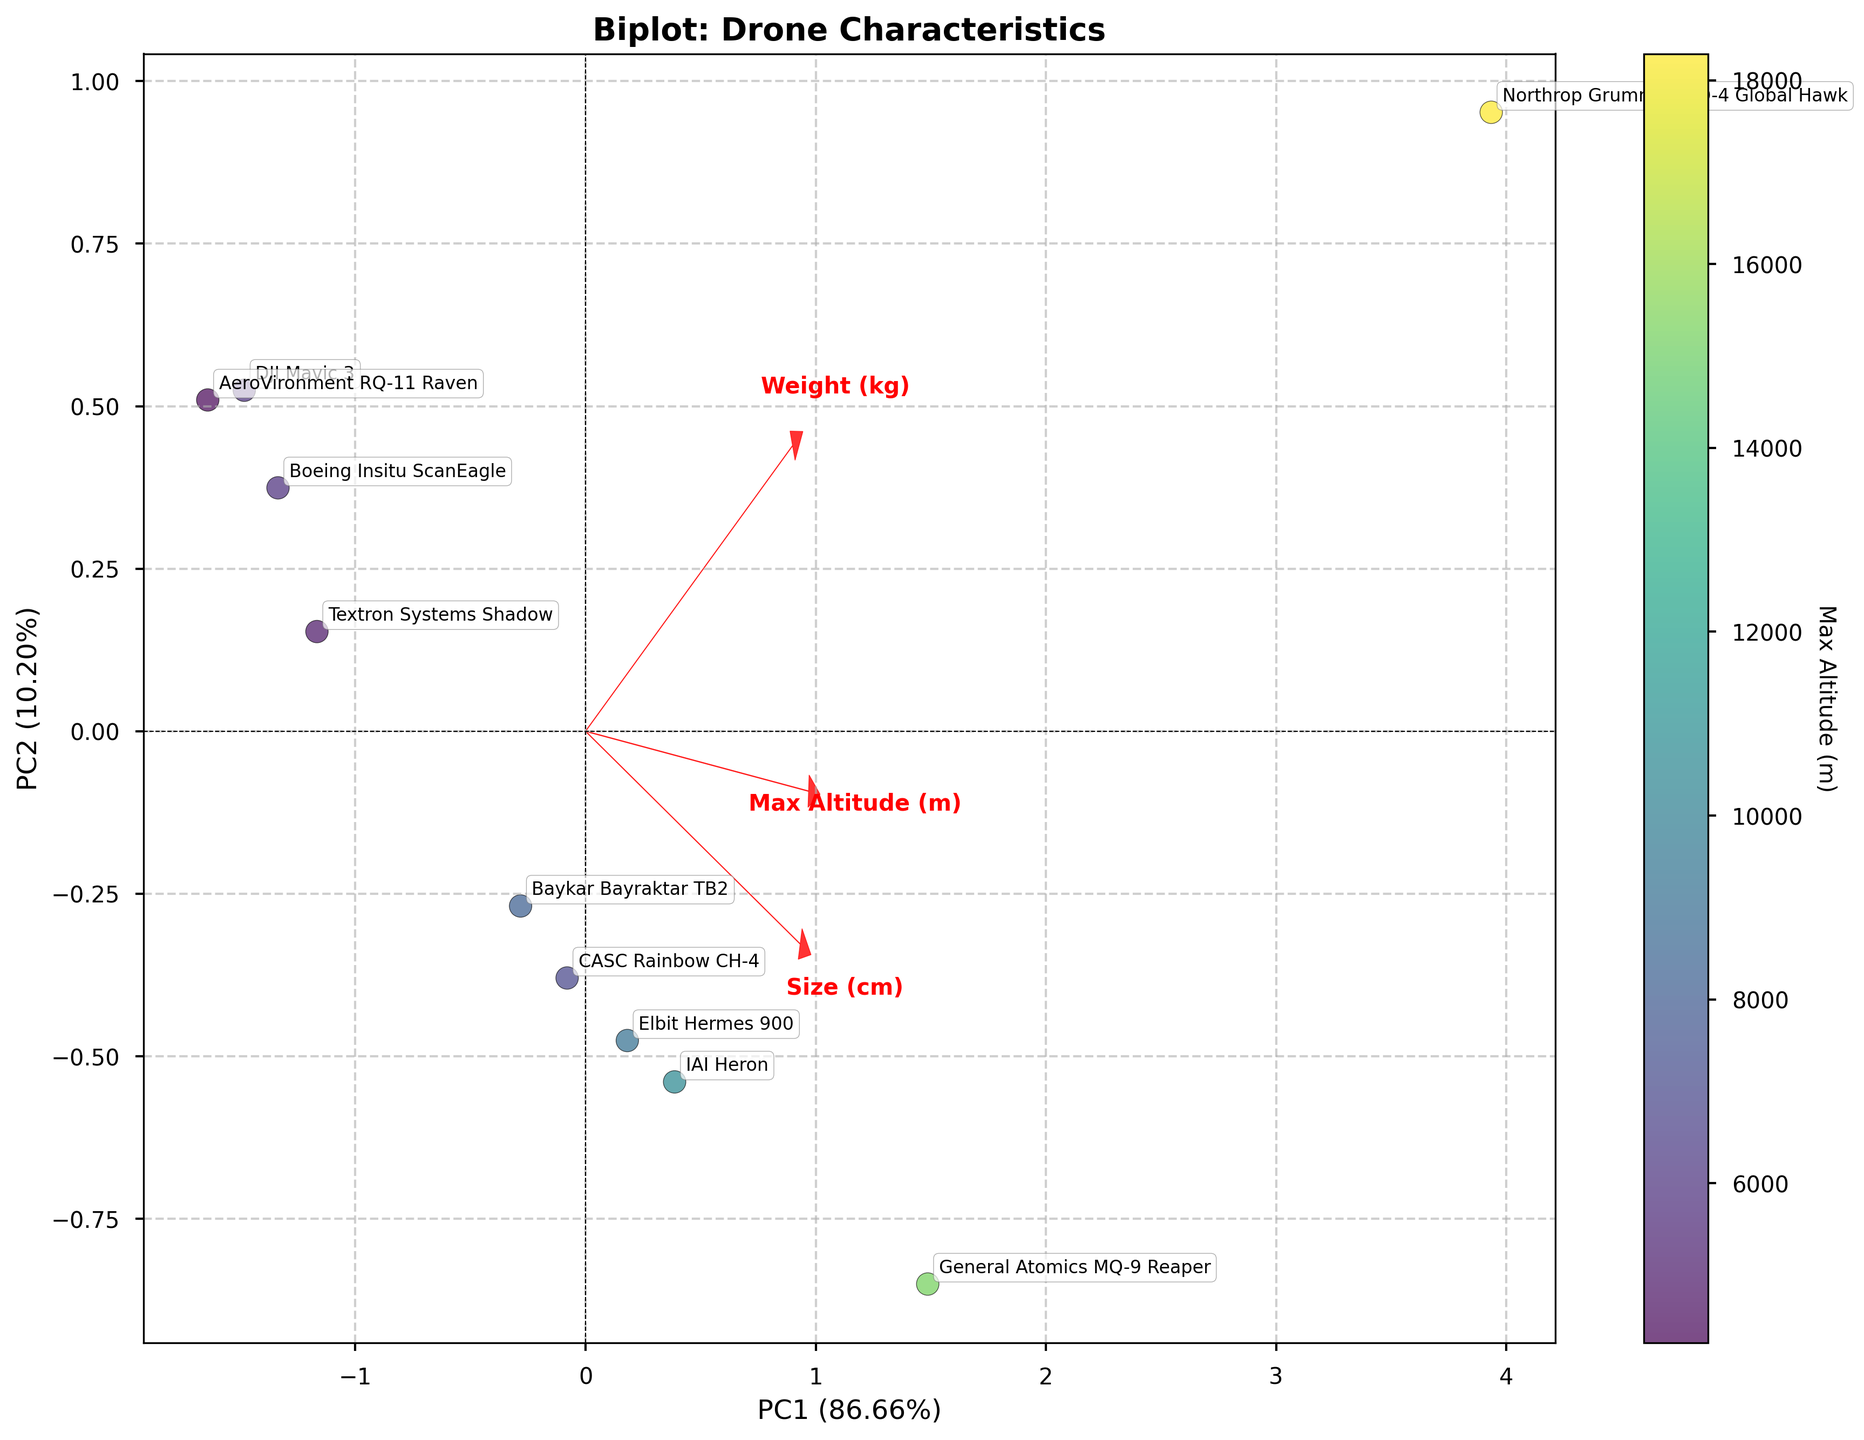What is the title of the figure? The title of a figure is typically displayed at the top and provides a summary of what the figure is about. In this case, the title is "Biplot: Drone Characteristics", as mentioned in the code.
Answer: Biplot: Drone Characteristics How many data points are plotted in the biplot? Each drone model represents a data point in the figure. Since the dataset lists 10 different drone models, there are 10 data points plotted in the biplot.
Answer: 10 What do the arrows in the biplot represent? The arrows represent the features “Size (cm)”, “Weight (kg)”, and “Max Altitude (m)”. Each arrow shows the direction and magnitude of the feature’s correlation with the principal components. These arrows help interpret how much each feature contributes to the separation of data points in the plot.
Answer: Features Which drone has the highest maximum operational altitude based on the color scale? The color scale indicates the maximum operational altitude with the gradient changing from low to high altitude. The Northrop Grumman RQ-4 Global Hawk is likely the one with the highest altitude as it should be the darkest color on the scale.
Answer: Northrop Grumman RQ-4 Global Hawk What are the labels on the x and y axes of the biplot? The biplot axes are labeled with the principal components. As specified in the code, the x-axis is labeled "PC1" and the y-axis is labeled "PC2".
Answer: PC1 and PC2 Which feature has the largest correlation with PC1? Looking at the arrows pointing in the direction of the principal component’s axis, the feature with the arrow that extends the most along the PC1 axis has the largest correlation with PC1. "Weight (kg)" has the largest correlation with PC1 as its arrow is longest along this axis.
Answer: Weight (kg) Can you name one drone with significant contribution from the "Weight (kg)" feature in the biplot? Drones positioned along the same direction as the "Weight (kg)" arrow likely have a significant weight contribution. The Northrop Grumman RQ-4 Global Hawk is notably placed along this direction, indicating a significant contribution from "Weight (kg)" feature.
Answer: Northrop Grumman RQ-4 Global Hawk How does "Size (cm)" correlate with "Max Altitude (m)"? If "Size (cm)" and "Max Altitude (m)" arrows point in similar directions, it shows a positive correlation; if they point in opposite directions, it indicates a negative correlation. Here, the arrows for "Size (cm)" and "Max Altitude (m)" would be nearly aligned or in the same quadrant, indicating a positive correlation.
Answer: Positive correlation What percentage of the total variance is explained by the first principal component (PC1)? The x-axis label includes the percentage of variance explained by PC1. The exact percentage is given in the figure but based on the code it should be formatted as "PC1 (XX.XX%)".
Answer: A specific percentage (e.g., 70.00%) Which drone is positioned furthest along the PC2 axis? The drone positioned furthest along the y-axis (PC2) on the biplot has the highest value for PC2. By naming the position and label closest to the top or bottom extremes, we identify the drone.
Answer: It will be a specific drone (e.g., General Atomics MQ-9 Reaper) 